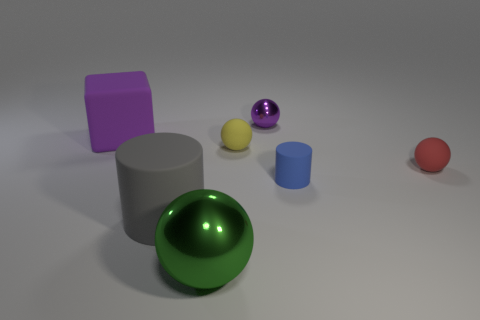Subtract all cyan balls. Subtract all purple blocks. How many balls are left? 4 Add 3 small gray matte blocks. How many objects exist? 10 Subtract all cubes. How many objects are left? 6 Add 1 large cylinders. How many large cylinders exist? 2 Subtract 0 red cylinders. How many objects are left? 7 Subtract all large gray cylinders. Subtract all tiny yellow matte spheres. How many objects are left? 5 Add 2 big spheres. How many big spheres are left? 3 